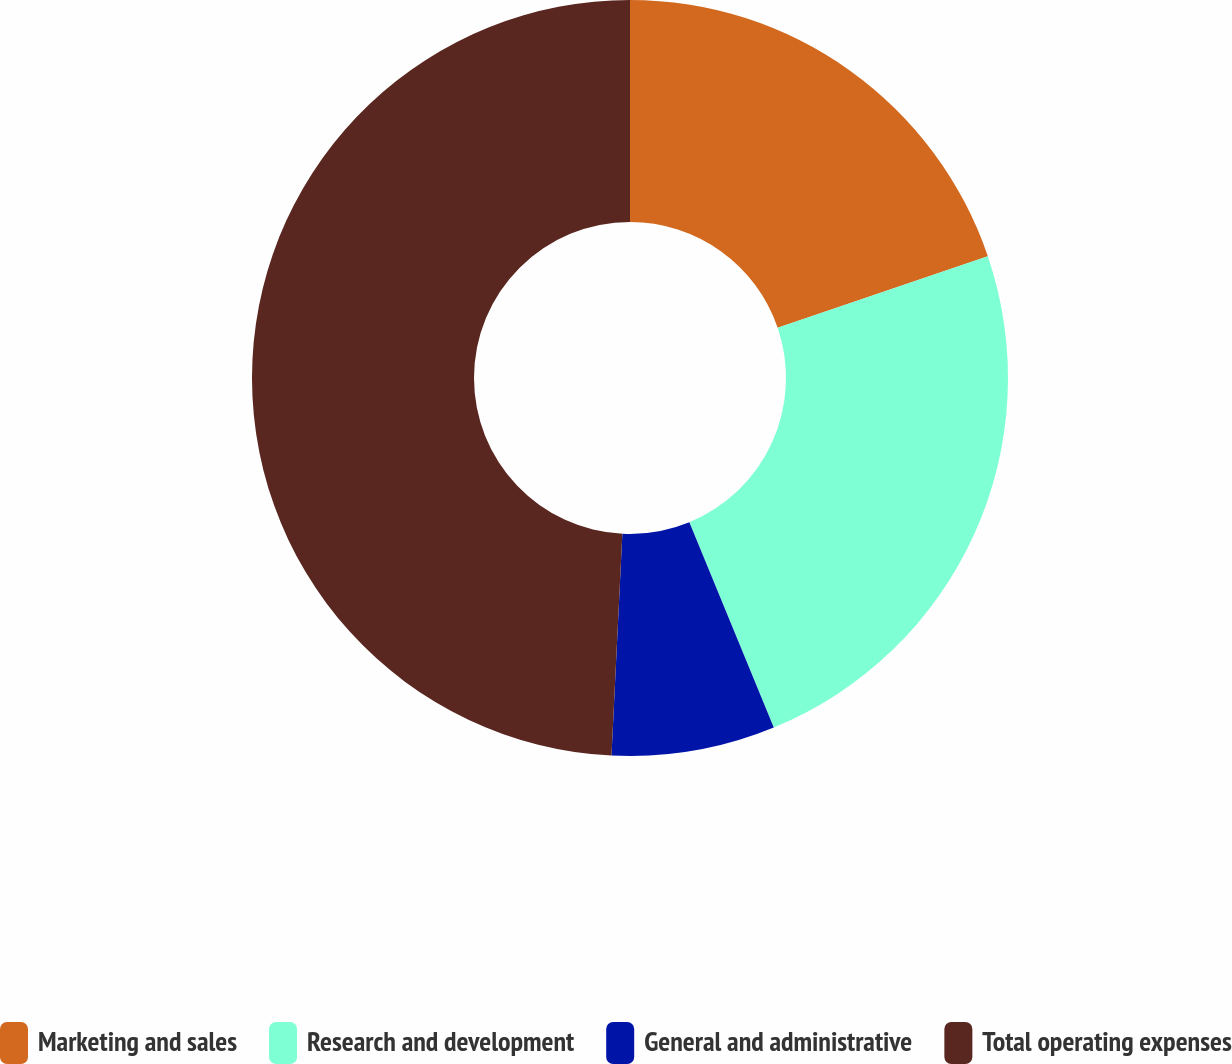Convert chart to OTSL. <chart><loc_0><loc_0><loc_500><loc_500><pie_chart><fcel>Marketing and sales<fcel>Research and development<fcel>General and administrative<fcel>Total operating expenses<nl><fcel>19.78%<fcel>24.01%<fcel>6.99%<fcel>49.22%<nl></chart> 